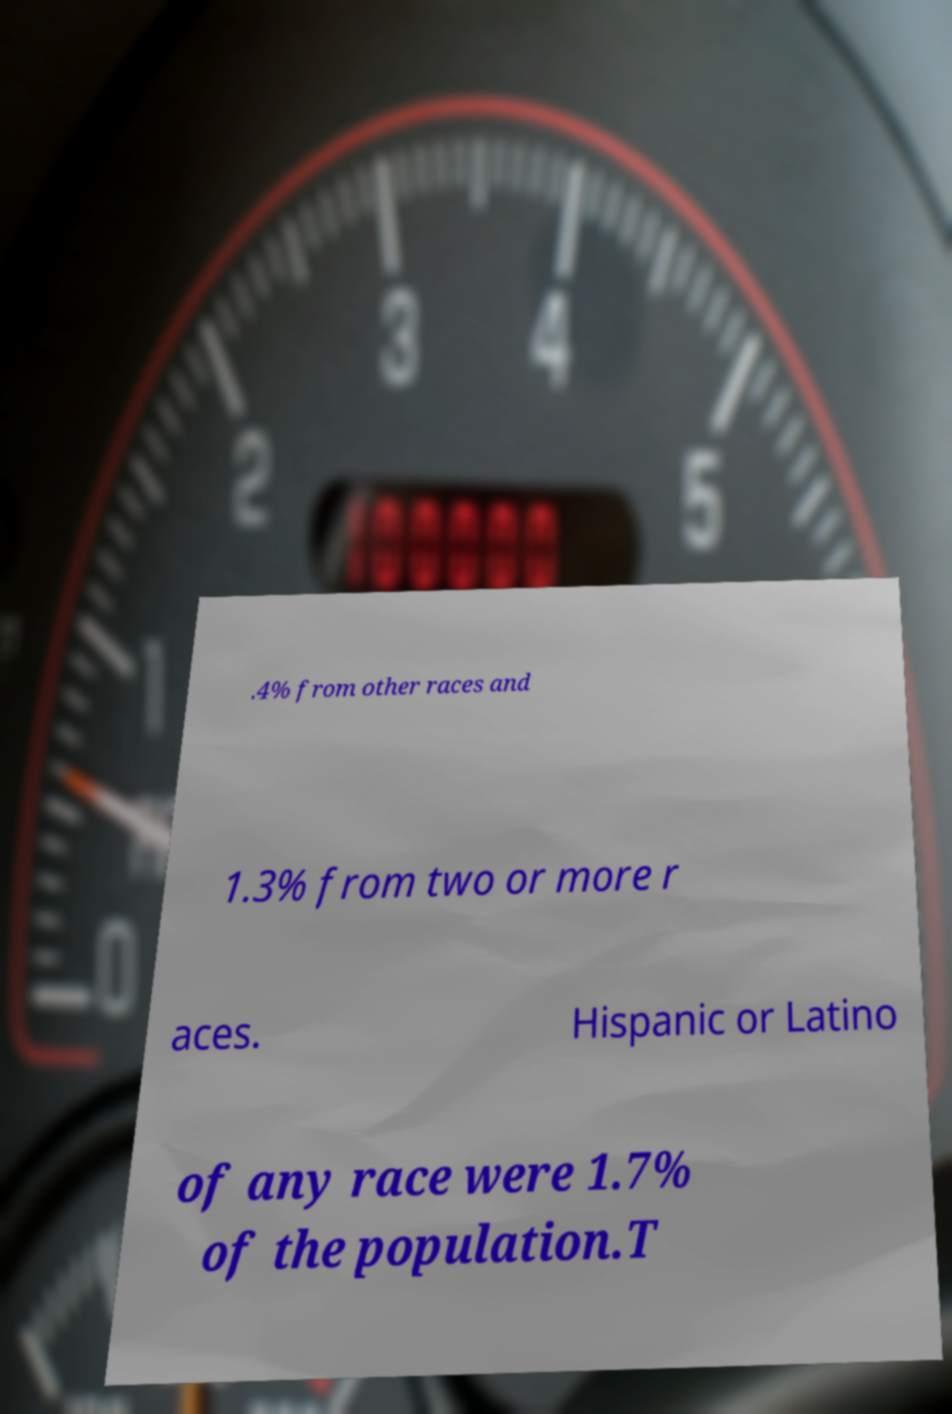For documentation purposes, I need the text within this image transcribed. Could you provide that? .4% from other races and 1.3% from two or more r aces. Hispanic or Latino of any race were 1.7% of the population.T 